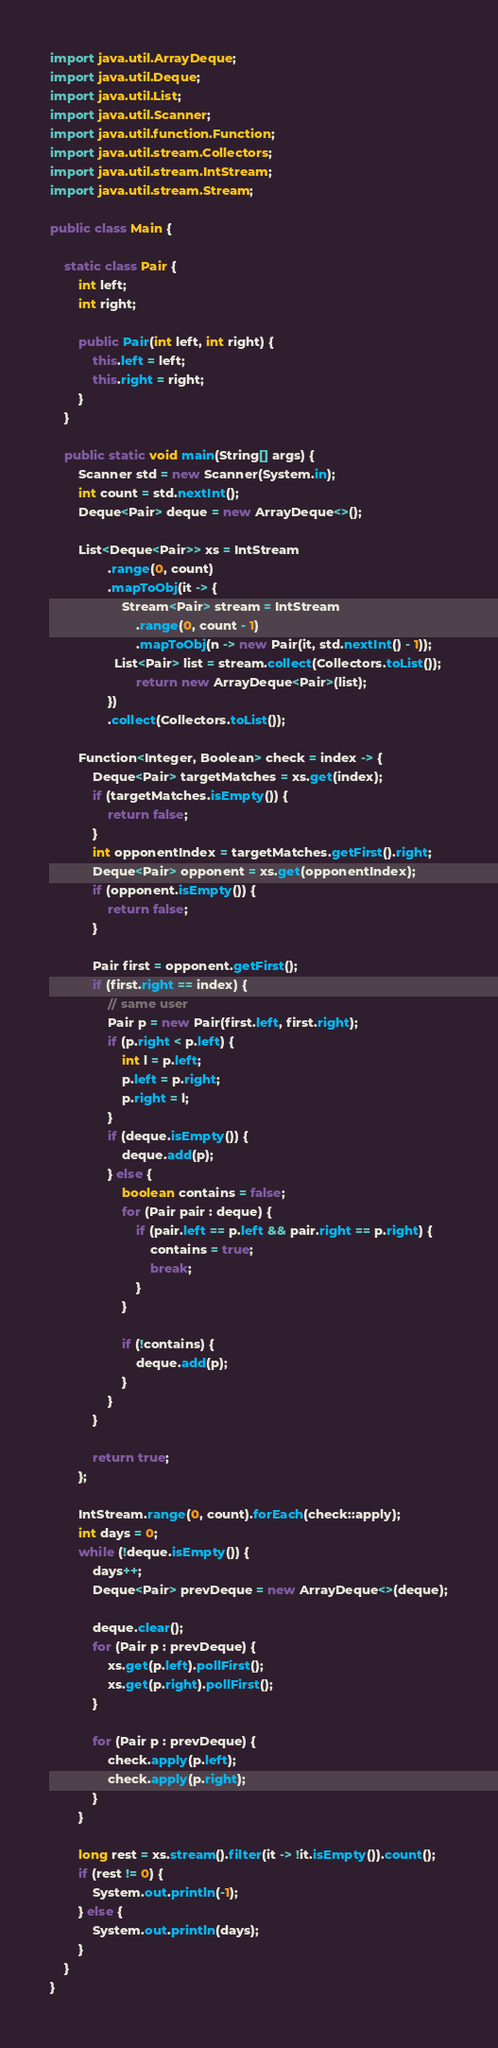<code> <loc_0><loc_0><loc_500><loc_500><_Java_>import java.util.ArrayDeque;
import java.util.Deque;
import java.util.List;
import java.util.Scanner;
import java.util.function.Function;
import java.util.stream.Collectors;
import java.util.stream.IntStream;
import java.util.stream.Stream;

public class Main {

    static class Pair {
        int left;
        int right;

        public Pair(int left, int right) {
            this.left = left;
            this.right = right;
        }
    }

    public static void main(String[] args) {
        Scanner std = new Scanner(System.in);
        int count = std.nextInt();
        Deque<Pair> deque = new ArrayDeque<>();

        List<Deque<Pair>> xs = IntStream
                .range(0, count)
                .mapToObj(it -> {
                    Stream<Pair> stream = IntStream
                        .range(0, count - 1)
                        .mapToObj(n -> new Pair(it, std.nextInt() - 1));
                  List<Pair> list = stream.collect(Collectors.toList());
                        return new ArrayDeque<Pair>(list);
                })
                .collect(Collectors.toList());

        Function<Integer, Boolean> check = index -> {
            Deque<Pair> targetMatches = xs.get(index);
            if (targetMatches.isEmpty()) {
                return false;
            }
            int opponentIndex = targetMatches.getFirst().right;
            Deque<Pair> opponent = xs.get(opponentIndex);
            if (opponent.isEmpty()) {
                return false;
            }

            Pair first = opponent.getFirst();
            if (first.right == index) {
                // same user
                Pair p = new Pair(first.left, first.right);
                if (p.right < p.left) {
                    int l = p.left;
                    p.left = p.right;
                    p.right = l;
                }
                if (deque.isEmpty()) {
                    deque.add(p);
                } else {
                    boolean contains = false;
                    for (Pair pair : deque) {
                        if (pair.left == p.left && pair.right == p.right) {
                            contains = true;
                            break;
                        }
                    }

                    if (!contains) {
                        deque.add(p);
                    }
                }
            }

            return true;
        };

        IntStream.range(0, count).forEach(check::apply);
        int days = 0;
        while (!deque.isEmpty()) {
            days++;
            Deque<Pair> prevDeque = new ArrayDeque<>(deque);

            deque.clear();
            for (Pair p : prevDeque) {
                xs.get(p.left).pollFirst();
                xs.get(p.right).pollFirst();
            }

            for (Pair p : prevDeque) {
                check.apply(p.left);
                check.apply(p.right);
            }
        }

        long rest = xs.stream().filter(it -> !it.isEmpty()).count();
        if (rest != 0) {
            System.out.println(-1);
        } else {
            System.out.println(days);
        }
    }
}
</code> 